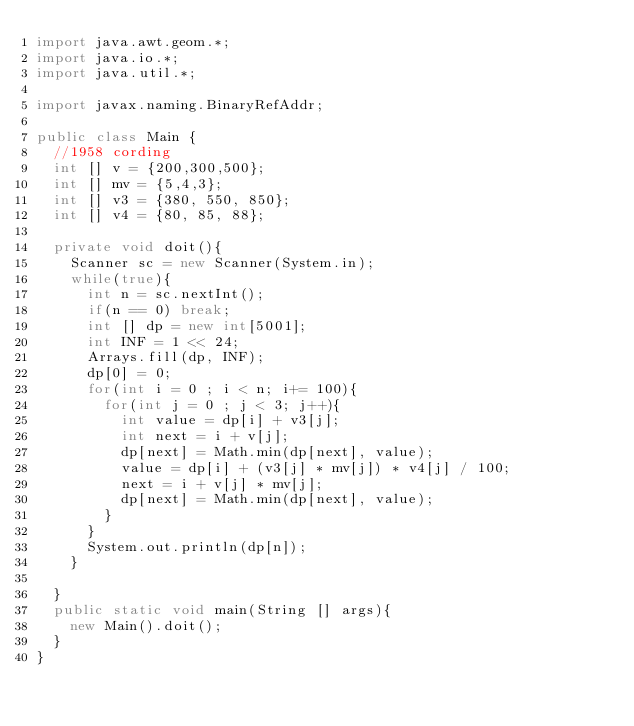Convert code to text. <code><loc_0><loc_0><loc_500><loc_500><_Java_>import java.awt.geom.*;
import java.io.*;
import java.util.*;

import javax.naming.BinaryRefAddr;

public class Main {
	//1958 cording
	int [] v = {200,300,500};
	int [] mv = {5,4,3};
	int [] v3 = {380, 550, 850};
	int [] v4 = {80, 85, 88};
	
	private void doit(){
		Scanner sc = new Scanner(System.in);
		while(true){
			int n = sc.nextInt();
			if(n == 0) break;
			int [] dp = new int[5001];
			int INF = 1 << 24;
			Arrays.fill(dp, INF);
			dp[0] = 0;
			for(int i = 0 ; i < n; i+= 100){
				for(int j = 0 ; j < 3; j++){
					int value = dp[i] + v3[j];
					int next = i + v[j];
					dp[next] = Math.min(dp[next], value);
					value = dp[i] + (v3[j] * mv[j]) * v4[j] / 100;
					next = i + v[j] * mv[j];
					dp[next] = Math.min(dp[next], value);
				}
			}
			System.out.println(dp[n]);
		}
	
	}
	public static void main(String [] args){
		new Main().doit();
	}
}</code> 